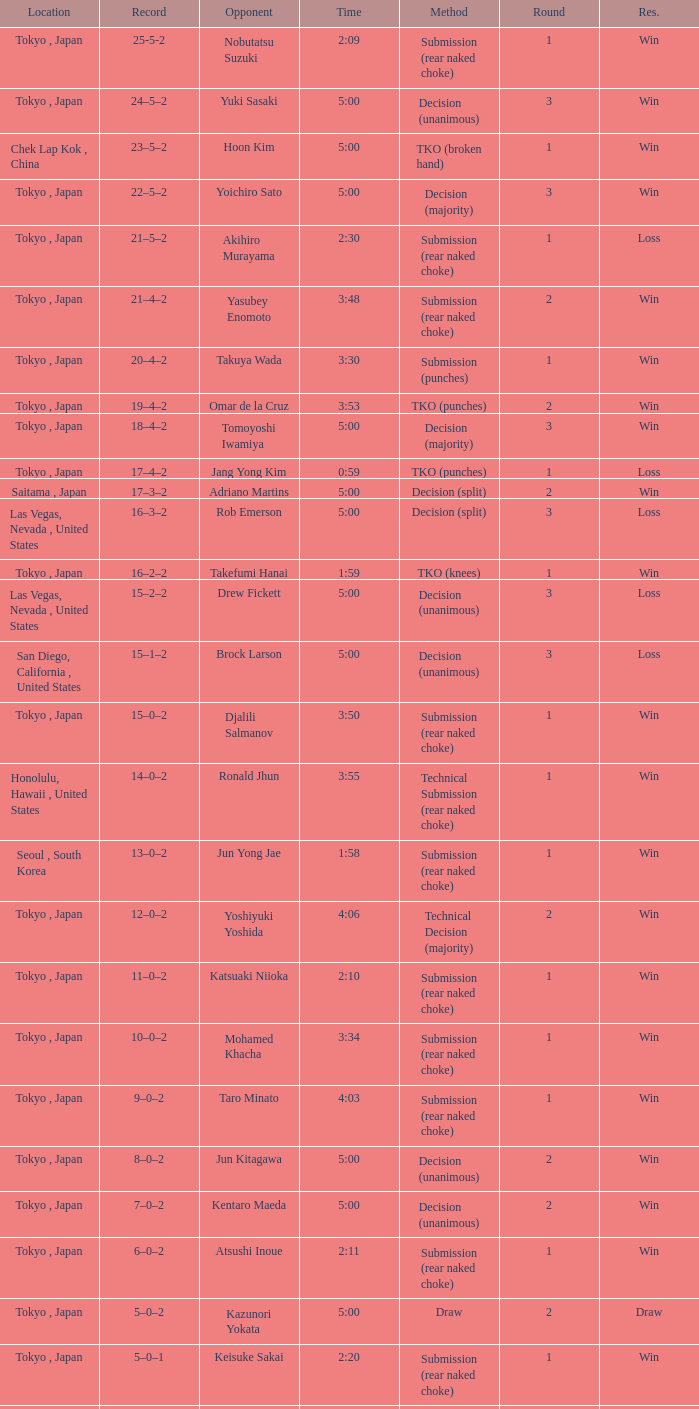Parse the table in full. {'header': ['Location', 'Record', 'Opponent', 'Time', 'Method', 'Round', 'Res.'], 'rows': [['Tokyo , Japan', '25-5-2', 'Nobutatsu Suzuki', '2:09', 'Submission (rear naked choke)', '1', 'Win'], ['Tokyo , Japan', '24–5–2', 'Yuki Sasaki', '5:00', 'Decision (unanimous)', '3', 'Win'], ['Chek Lap Kok , China', '23–5–2', 'Hoon Kim', '5:00', 'TKO (broken hand)', '1', 'Win'], ['Tokyo , Japan', '22–5–2', 'Yoichiro Sato', '5:00', 'Decision (majority)', '3', 'Win'], ['Tokyo , Japan', '21–5–2', 'Akihiro Murayama', '2:30', 'Submission (rear naked choke)', '1', 'Loss'], ['Tokyo , Japan', '21–4–2', 'Yasubey Enomoto', '3:48', 'Submission (rear naked choke)', '2', 'Win'], ['Tokyo , Japan', '20–4–2', 'Takuya Wada', '3:30', 'Submission (punches)', '1', 'Win'], ['Tokyo , Japan', '19–4–2', 'Omar de la Cruz', '3:53', 'TKO (punches)', '2', 'Win'], ['Tokyo , Japan', '18–4–2', 'Tomoyoshi Iwamiya', '5:00', 'Decision (majority)', '3', 'Win'], ['Tokyo , Japan', '17–4–2', 'Jang Yong Kim', '0:59', 'TKO (punches)', '1', 'Loss'], ['Saitama , Japan', '17–3–2', 'Adriano Martins', '5:00', 'Decision (split)', '2', 'Win'], ['Las Vegas, Nevada , United States', '16–3–2', 'Rob Emerson', '5:00', 'Decision (split)', '3', 'Loss'], ['Tokyo , Japan', '16–2–2', 'Takefumi Hanai', '1:59', 'TKO (knees)', '1', 'Win'], ['Las Vegas, Nevada , United States', '15–2–2', 'Drew Fickett', '5:00', 'Decision (unanimous)', '3', 'Loss'], ['San Diego, California , United States', '15–1–2', 'Brock Larson', '5:00', 'Decision (unanimous)', '3', 'Loss'], ['Tokyo , Japan', '15–0–2', 'Djalili Salmanov', '3:50', 'Submission (rear naked choke)', '1', 'Win'], ['Honolulu, Hawaii , United States', '14–0–2', 'Ronald Jhun', '3:55', 'Technical Submission (rear naked choke)', '1', 'Win'], ['Seoul , South Korea', '13–0–2', 'Jun Yong Jae', '1:58', 'Submission (rear naked choke)', '1', 'Win'], ['Tokyo , Japan', '12–0–2', 'Yoshiyuki Yoshida', '4:06', 'Technical Decision (majority)', '2', 'Win'], ['Tokyo , Japan', '11–0–2', 'Katsuaki Niioka', '2:10', 'Submission (rear naked choke)', '1', 'Win'], ['Tokyo , Japan', '10–0–2', 'Mohamed Khacha', '3:34', 'Submission (rear naked choke)', '1', 'Win'], ['Tokyo , Japan', '9–0–2', 'Taro Minato', '4:03', 'Submission (rear naked choke)', '1', 'Win'], ['Tokyo , Japan', '8–0–2', 'Jun Kitagawa', '5:00', 'Decision (unanimous)', '2', 'Win'], ['Tokyo , Japan', '7–0–2', 'Kentaro Maeda', '5:00', 'Decision (unanimous)', '2', 'Win'], ['Tokyo , Japan', '6–0–2', 'Atsushi Inoue', '2:11', 'Submission (rear naked choke)', '1', 'Win'], ['Tokyo , Japan', '5–0–2', 'Kazunori Yokata', '5:00', 'Draw', '2', 'Draw'], ['Tokyo , Japan', '5–0–1', 'Keisuke Sakai', '2:20', 'Submission (rear naked choke)', '1', 'Win'], ['Tokyo , Japan', '4–0–1', 'Ichiro Kanai', '5:00', 'Decision (unanimous)', '2', 'Win'], ['Tokyo , Japan', '3–0–1', 'Daisuke Nakamura', '5:00', 'Decision (unanimous)', '2', 'Win'], ['Tokyo , Japan', '2–0–1', 'Ichiro Kanai', '5:00', 'Draw', '2', 'Draw'], ['Tokyo , Japan', '2–0', 'Kenta Omori', '7:44', 'Submission (triangle choke)', '1', 'Win'], ['Tokyo , Japan', '1–0', 'Tomohito Tanizaki', '0:33', 'TKO (punches)', '1', 'Win']]} What is the total number of rounds when Drew Fickett was the opponent and the time is 5:00? 1.0. 